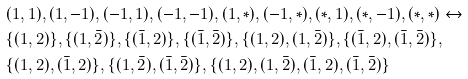<formula> <loc_0><loc_0><loc_500><loc_500>& ( 1 , 1 ) , ( 1 , - 1 ) , ( - 1 , 1 ) , ( - 1 , - 1 ) , ( 1 , \ast ) , ( - 1 , \ast ) , ( \ast , 1 ) , ( \ast , - 1 ) , ( \ast , \ast ) \leftrightarrow \\ & \{ ( 1 , 2 ) \} , \{ ( 1 , \bar { 2 } ) \} , \{ ( \bar { 1 } , 2 ) \} , \{ ( \bar { 1 } , \bar { 2 } ) \} , \{ ( 1 , 2 ) , ( 1 , \bar { 2 } ) \} , \{ ( \bar { 1 } , 2 ) , ( \bar { 1 } , \bar { 2 } ) \} , \\ & \{ ( 1 , 2 ) , ( \bar { 1 } , 2 ) \} , \{ ( 1 , \bar { 2 } ) , ( \bar { 1 } , \bar { 2 } ) \} , \{ ( 1 , 2 ) , ( 1 , \bar { 2 } ) , ( \bar { 1 } , 2 ) , ( \bar { 1 } , \bar { 2 } ) \}</formula> 